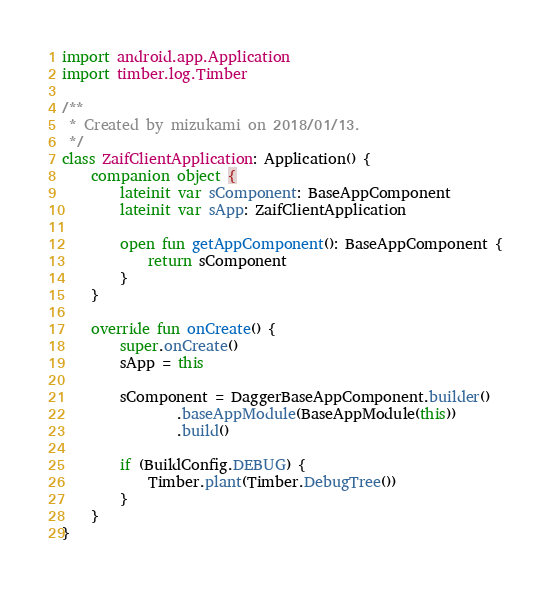Convert code to text. <code><loc_0><loc_0><loc_500><loc_500><_Kotlin_>import android.app.Application
import timber.log.Timber

/**
 * Created by mizukami on 2018/01/13.
 */
class ZaifClientApplication: Application() {
    companion object {
        lateinit var sComponent: BaseAppComponent
        lateinit var sApp: ZaifClientApplication

        open fun getAppComponent(): BaseAppComponent {
            return sComponent
        }
    }

    override fun onCreate() {
        super.onCreate()
        sApp = this

        sComponent = DaggerBaseAppComponent.builder()
                .baseAppModule(BaseAppModule(this))
                .build()

        if (BuildConfig.DEBUG) {
            Timber.plant(Timber.DebugTree())
        }
    }
}

</code> 